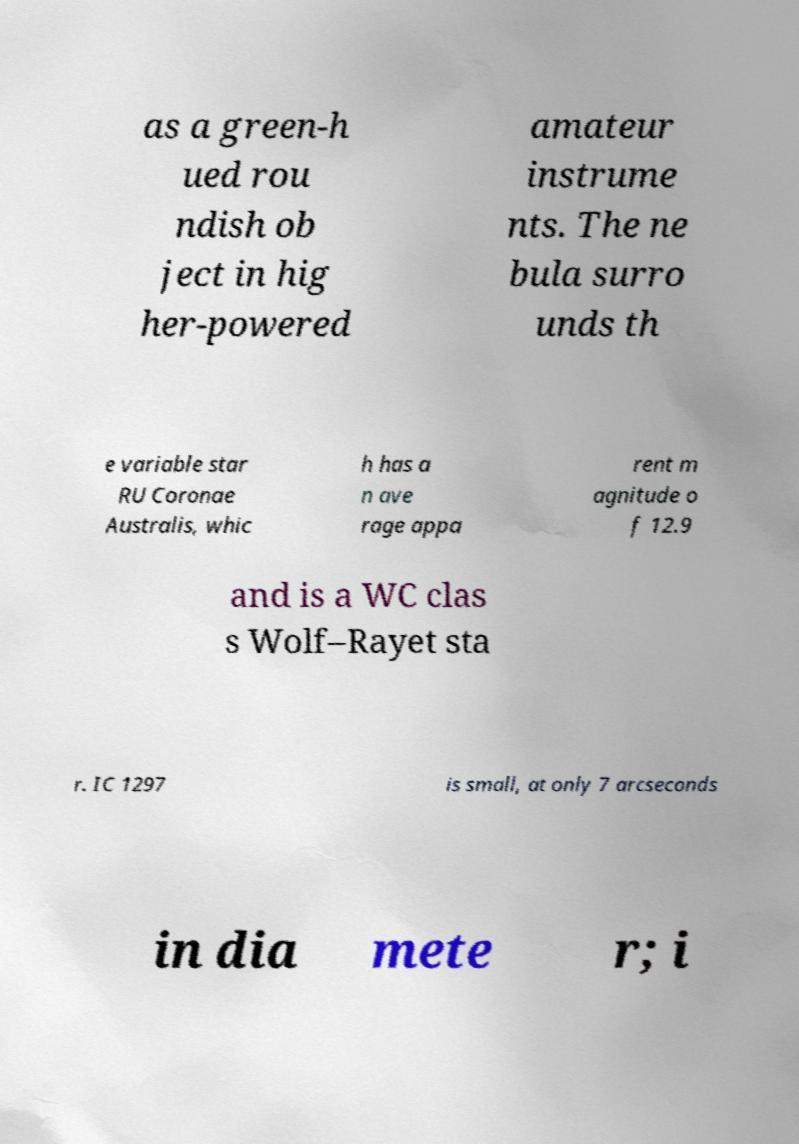Could you extract and type out the text from this image? as a green-h ued rou ndish ob ject in hig her-powered amateur instrume nts. The ne bula surro unds th e variable star RU Coronae Australis, whic h has a n ave rage appa rent m agnitude o f 12.9 and is a WC clas s Wolf–Rayet sta r. IC 1297 is small, at only 7 arcseconds in dia mete r; i 